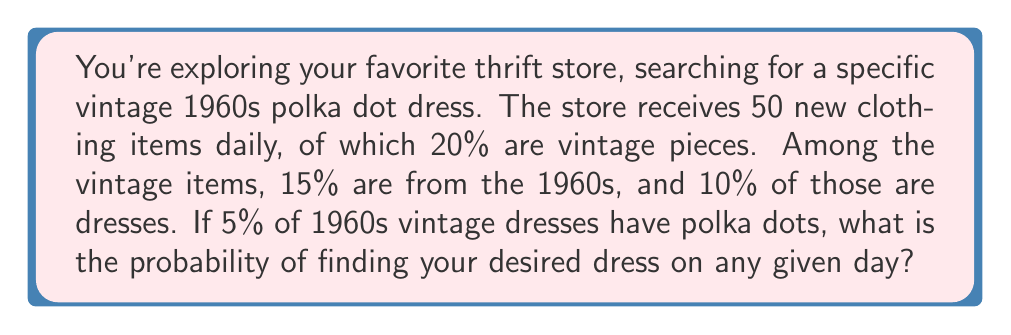Can you solve this math problem? Let's break this down step-by-step:

1) First, calculate the number of vintage items received daily:
   $20\% \text{ of } 50 = 0.20 \times 50 = 10$ vintage items

2) Next, calculate the number of 1960s vintage items:
   $15\% \text{ of } 10 = 0.15 \times 10 = 1.5$ 1960s vintage items

3) Calculate the number of 1960s vintage dresses:
   $10\% \text{ of } 1.5 = 0.10 \times 1.5 = 0.15$ 1960s vintage dresses

4) Finally, calculate the number of 1960s vintage polka dot dresses:
   $5\% \text{ of } 0.15 = 0.05 \times 0.15 = 0.0075$

5) The probability is thus 0.0075, or 75 in 10,000.

We can also express this as a single calculation:

$$P(\text{1960s polka dot dress}) = 50 \times 0.20 \times 0.15 \times 0.10 \times 0.05 = 0.0075$$
Answer: $0.0075$ or $\frac{75}{10000}$ 